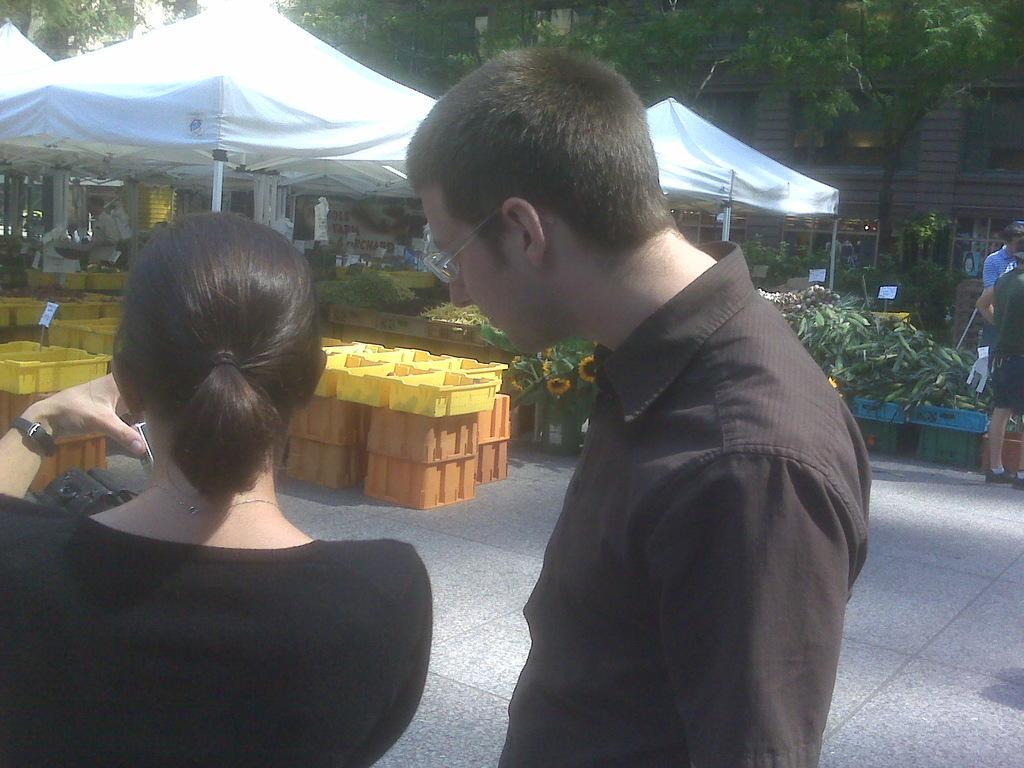Could you give a brief overview of what you see in this image? In this picture we can see two persons. There are baskets, plants, flowers, tents, boards, and few persons. In the background there are trees and a building. 